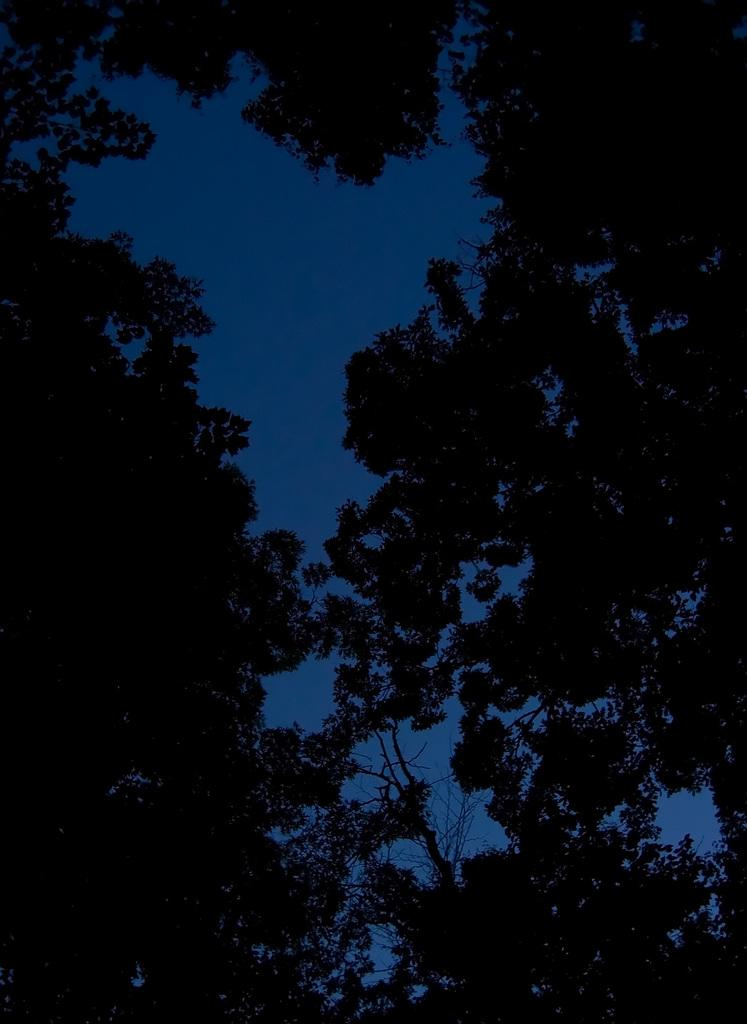What type of natural environment is depicted in the image? The image features many trees, suggesting a forest or wooded area. What can be seen in the sky in the image? The sky is visible in the image, but no specific details about the sky are provided. Can you describe the person sitting on the robin in the image? There is no person or robin present in the image; it features many trees and a visible sky. 